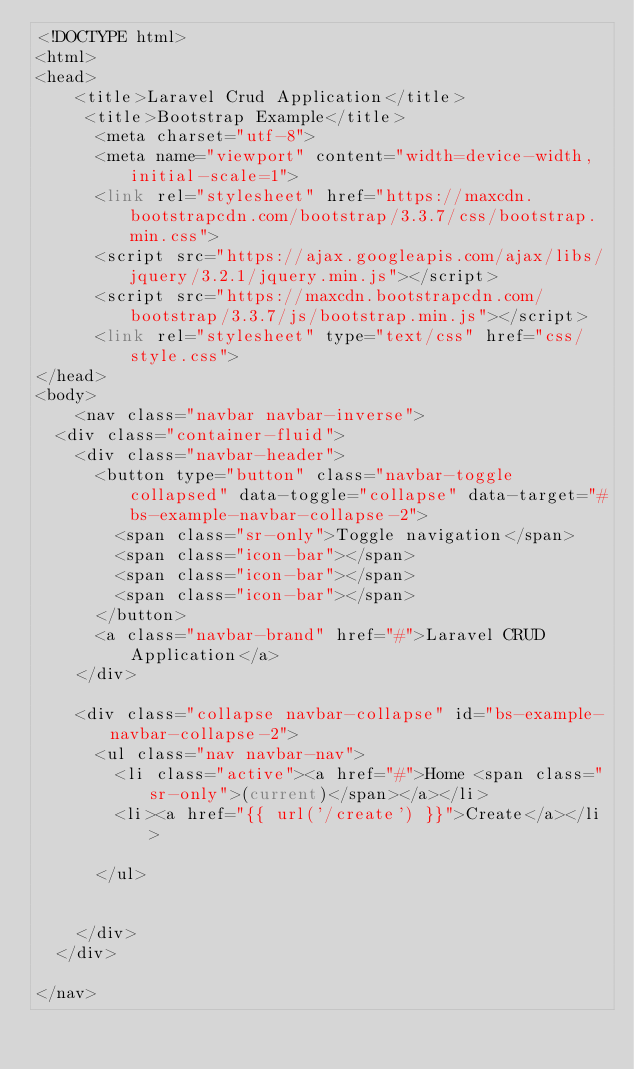Convert code to text. <code><loc_0><loc_0><loc_500><loc_500><_PHP_><!DOCTYPE html>
<html>
<head>
	<title>Laravel Crud Application</title>
	 <title>Bootstrap Example</title>
	  <meta charset="utf-8">
	  <meta name="viewport" content="width=device-width, initial-scale=1">
	  <link rel="stylesheet" href="https://maxcdn.bootstrapcdn.com/bootstrap/3.3.7/css/bootstrap.min.css">
	  <script src="https://ajax.googleapis.com/ajax/libs/jquery/3.2.1/jquery.min.js"></script>
	  <script src="https://maxcdn.bootstrapcdn.com/bootstrap/3.3.7/js/bootstrap.min.js"></script>
	  <link rel="stylesheet" type="text/css" href="css/style.css">
</head>
<body>
	<nav class="navbar navbar-inverse">
  <div class="container-fluid">
    <div class="navbar-header">
      <button type="button" class="navbar-toggle collapsed" data-toggle="collapse" data-target="#bs-example-navbar-collapse-2">
        <span class="sr-only">Toggle navigation</span>
        <span class="icon-bar"></span>
        <span class="icon-bar"></span>
        <span class="icon-bar"></span>
      </button>
      <a class="navbar-brand" href="#">Laravel CRUD Application</a>
    </div>

    <div class="collapse navbar-collapse" id="bs-example-navbar-collapse-2">
      <ul class="nav navbar-nav">
        <li class="active"><a href="#">Home <span class="sr-only">(current)</span></a></li>
        <li><a href="{{ url('/create') }}">Create</a></li>
       
      </ul>
      
      
    </div>
  </div>

</nav>
</code> 